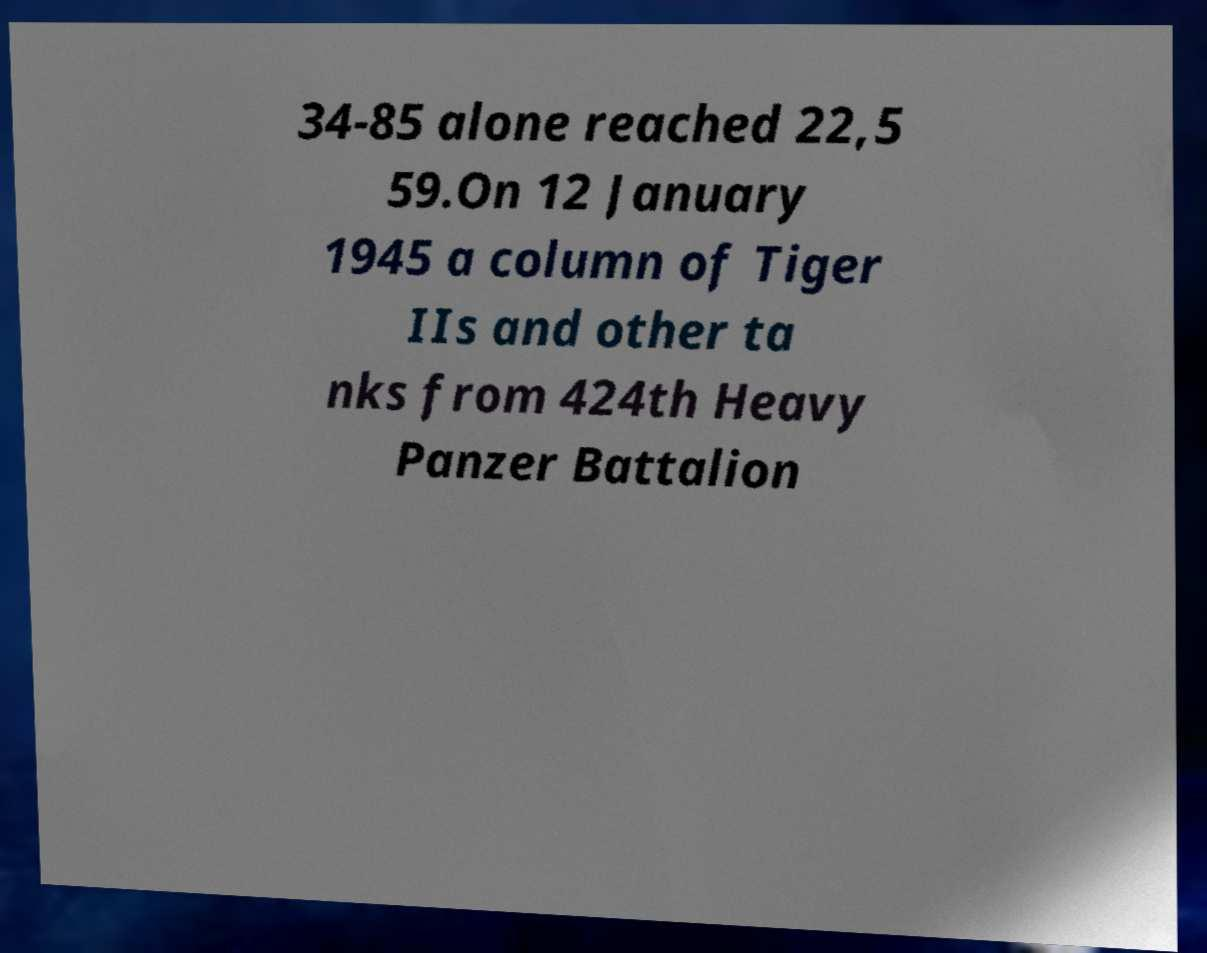For documentation purposes, I need the text within this image transcribed. Could you provide that? 34-85 alone reached 22,5 59.On 12 January 1945 a column of Tiger IIs and other ta nks from 424th Heavy Panzer Battalion 